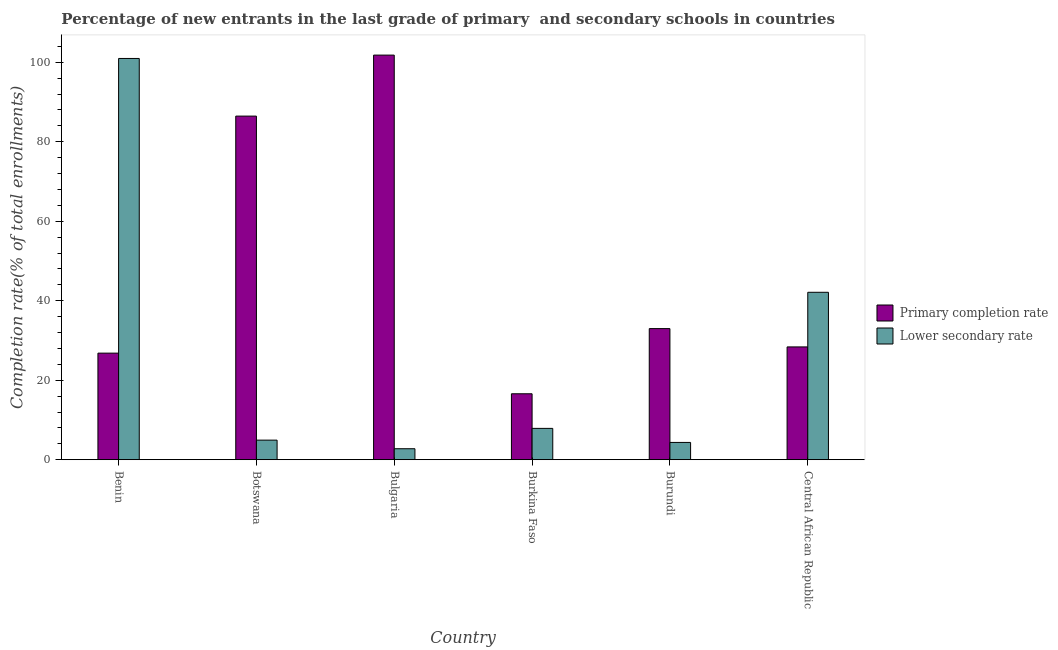How many different coloured bars are there?
Your answer should be compact. 2. How many groups of bars are there?
Ensure brevity in your answer.  6. Are the number of bars on each tick of the X-axis equal?
Offer a very short reply. Yes. How many bars are there on the 4th tick from the left?
Your response must be concise. 2. How many bars are there on the 4th tick from the right?
Provide a short and direct response. 2. What is the label of the 6th group of bars from the left?
Your response must be concise. Central African Republic. What is the completion rate in secondary schools in Burundi?
Make the answer very short. 4.35. Across all countries, what is the maximum completion rate in secondary schools?
Provide a succinct answer. 100.95. Across all countries, what is the minimum completion rate in secondary schools?
Ensure brevity in your answer.  2.76. In which country was the completion rate in primary schools maximum?
Give a very brief answer. Bulgaria. In which country was the completion rate in primary schools minimum?
Offer a terse response. Burkina Faso. What is the total completion rate in secondary schools in the graph?
Offer a terse response. 162.97. What is the difference between the completion rate in secondary schools in Botswana and that in Central African Republic?
Provide a succinct answer. -37.19. What is the difference between the completion rate in secondary schools in Burundi and the completion rate in primary schools in Botswana?
Keep it short and to the point. -82.1. What is the average completion rate in secondary schools per country?
Provide a short and direct response. 27.16. What is the difference between the completion rate in secondary schools and completion rate in primary schools in Bulgaria?
Keep it short and to the point. -99.03. In how many countries, is the completion rate in primary schools greater than 8 %?
Provide a succinct answer. 6. What is the ratio of the completion rate in secondary schools in Bulgaria to that in Burkina Faso?
Provide a succinct answer. 0.35. Is the completion rate in primary schools in Benin less than that in Burundi?
Make the answer very short. Yes. Is the difference between the completion rate in primary schools in Bulgaria and Burundi greater than the difference between the completion rate in secondary schools in Bulgaria and Burundi?
Give a very brief answer. Yes. What is the difference between the highest and the second highest completion rate in primary schools?
Provide a short and direct response. 15.35. What is the difference between the highest and the lowest completion rate in primary schools?
Your response must be concise. 85.2. What does the 1st bar from the left in Botswana represents?
Offer a very short reply. Primary completion rate. What does the 1st bar from the right in Central African Republic represents?
Offer a terse response. Lower secondary rate. What is the difference between two consecutive major ticks on the Y-axis?
Ensure brevity in your answer.  20. Does the graph contain any zero values?
Offer a very short reply. No. Where does the legend appear in the graph?
Your answer should be compact. Center right. How are the legend labels stacked?
Your response must be concise. Vertical. What is the title of the graph?
Make the answer very short. Percentage of new entrants in the last grade of primary  and secondary schools in countries. Does "Net savings(excluding particulate emission damage)" appear as one of the legend labels in the graph?
Offer a very short reply. No. What is the label or title of the Y-axis?
Your answer should be very brief. Completion rate(% of total enrollments). What is the Completion rate(% of total enrollments) in Primary completion rate in Benin?
Keep it short and to the point. 26.81. What is the Completion rate(% of total enrollments) in Lower secondary rate in Benin?
Provide a short and direct response. 100.95. What is the Completion rate(% of total enrollments) of Primary completion rate in Botswana?
Provide a short and direct response. 86.44. What is the Completion rate(% of total enrollments) in Lower secondary rate in Botswana?
Your answer should be compact. 4.92. What is the Completion rate(% of total enrollments) of Primary completion rate in Bulgaria?
Ensure brevity in your answer.  101.79. What is the Completion rate(% of total enrollments) of Lower secondary rate in Bulgaria?
Make the answer very short. 2.76. What is the Completion rate(% of total enrollments) of Primary completion rate in Burkina Faso?
Offer a terse response. 16.59. What is the Completion rate(% of total enrollments) of Lower secondary rate in Burkina Faso?
Your response must be concise. 7.88. What is the Completion rate(% of total enrollments) of Primary completion rate in Burundi?
Make the answer very short. 32.98. What is the Completion rate(% of total enrollments) of Lower secondary rate in Burundi?
Your answer should be very brief. 4.35. What is the Completion rate(% of total enrollments) in Primary completion rate in Central African Republic?
Offer a terse response. 28.38. What is the Completion rate(% of total enrollments) in Lower secondary rate in Central African Republic?
Your answer should be compact. 42.12. Across all countries, what is the maximum Completion rate(% of total enrollments) in Primary completion rate?
Your response must be concise. 101.79. Across all countries, what is the maximum Completion rate(% of total enrollments) of Lower secondary rate?
Your answer should be compact. 100.95. Across all countries, what is the minimum Completion rate(% of total enrollments) in Primary completion rate?
Ensure brevity in your answer.  16.59. Across all countries, what is the minimum Completion rate(% of total enrollments) in Lower secondary rate?
Keep it short and to the point. 2.76. What is the total Completion rate(% of total enrollments) in Primary completion rate in the graph?
Your answer should be compact. 292.99. What is the total Completion rate(% of total enrollments) of Lower secondary rate in the graph?
Your answer should be compact. 162.97. What is the difference between the Completion rate(% of total enrollments) in Primary completion rate in Benin and that in Botswana?
Offer a very short reply. -59.63. What is the difference between the Completion rate(% of total enrollments) in Lower secondary rate in Benin and that in Botswana?
Provide a succinct answer. 96.02. What is the difference between the Completion rate(% of total enrollments) in Primary completion rate in Benin and that in Bulgaria?
Your answer should be very brief. -74.98. What is the difference between the Completion rate(% of total enrollments) in Lower secondary rate in Benin and that in Bulgaria?
Offer a terse response. 98.19. What is the difference between the Completion rate(% of total enrollments) of Primary completion rate in Benin and that in Burkina Faso?
Offer a terse response. 10.22. What is the difference between the Completion rate(% of total enrollments) of Lower secondary rate in Benin and that in Burkina Faso?
Your answer should be very brief. 93.07. What is the difference between the Completion rate(% of total enrollments) of Primary completion rate in Benin and that in Burundi?
Offer a very short reply. -6.17. What is the difference between the Completion rate(% of total enrollments) of Lower secondary rate in Benin and that in Burundi?
Your answer should be compact. 96.6. What is the difference between the Completion rate(% of total enrollments) in Primary completion rate in Benin and that in Central African Republic?
Ensure brevity in your answer.  -1.56. What is the difference between the Completion rate(% of total enrollments) in Lower secondary rate in Benin and that in Central African Republic?
Offer a terse response. 58.83. What is the difference between the Completion rate(% of total enrollments) of Primary completion rate in Botswana and that in Bulgaria?
Your answer should be compact. -15.35. What is the difference between the Completion rate(% of total enrollments) of Lower secondary rate in Botswana and that in Bulgaria?
Your answer should be compact. 2.16. What is the difference between the Completion rate(% of total enrollments) of Primary completion rate in Botswana and that in Burkina Faso?
Make the answer very short. 69.86. What is the difference between the Completion rate(% of total enrollments) of Lower secondary rate in Botswana and that in Burkina Faso?
Your answer should be very brief. -2.95. What is the difference between the Completion rate(% of total enrollments) in Primary completion rate in Botswana and that in Burundi?
Offer a terse response. 53.46. What is the difference between the Completion rate(% of total enrollments) of Lower secondary rate in Botswana and that in Burundi?
Make the answer very short. 0.58. What is the difference between the Completion rate(% of total enrollments) of Primary completion rate in Botswana and that in Central African Republic?
Your answer should be very brief. 58.07. What is the difference between the Completion rate(% of total enrollments) in Lower secondary rate in Botswana and that in Central African Republic?
Give a very brief answer. -37.19. What is the difference between the Completion rate(% of total enrollments) in Primary completion rate in Bulgaria and that in Burkina Faso?
Offer a terse response. 85.2. What is the difference between the Completion rate(% of total enrollments) in Lower secondary rate in Bulgaria and that in Burkina Faso?
Your answer should be very brief. -5.12. What is the difference between the Completion rate(% of total enrollments) of Primary completion rate in Bulgaria and that in Burundi?
Your answer should be compact. 68.81. What is the difference between the Completion rate(% of total enrollments) of Lower secondary rate in Bulgaria and that in Burundi?
Your answer should be very brief. -1.59. What is the difference between the Completion rate(% of total enrollments) of Primary completion rate in Bulgaria and that in Central African Republic?
Keep it short and to the point. 73.41. What is the difference between the Completion rate(% of total enrollments) of Lower secondary rate in Bulgaria and that in Central African Republic?
Offer a terse response. -39.36. What is the difference between the Completion rate(% of total enrollments) in Primary completion rate in Burkina Faso and that in Burundi?
Your response must be concise. -16.4. What is the difference between the Completion rate(% of total enrollments) of Lower secondary rate in Burkina Faso and that in Burundi?
Offer a very short reply. 3.53. What is the difference between the Completion rate(% of total enrollments) in Primary completion rate in Burkina Faso and that in Central African Republic?
Make the answer very short. -11.79. What is the difference between the Completion rate(% of total enrollments) in Lower secondary rate in Burkina Faso and that in Central African Republic?
Keep it short and to the point. -34.24. What is the difference between the Completion rate(% of total enrollments) in Primary completion rate in Burundi and that in Central African Republic?
Ensure brevity in your answer.  4.61. What is the difference between the Completion rate(% of total enrollments) of Lower secondary rate in Burundi and that in Central African Republic?
Give a very brief answer. -37.77. What is the difference between the Completion rate(% of total enrollments) in Primary completion rate in Benin and the Completion rate(% of total enrollments) in Lower secondary rate in Botswana?
Make the answer very short. 21.89. What is the difference between the Completion rate(% of total enrollments) in Primary completion rate in Benin and the Completion rate(% of total enrollments) in Lower secondary rate in Bulgaria?
Provide a short and direct response. 24.05. What is the difference between the Completion rate(% of total enrollments) of Primary completion rate in Benin and the Completion rate(% of total enrollments) of Lower secondary rate in Burkina Faso?
Your answer should be very brief. 18.93. What is the difference between the Completion rate(% of total enrollments) in Primary completion rate in Benin and the Completion rate(% of total enrollments) in Lower secondary rate in Burundi?
Keep it short and to the point. 22.47. What is the difference between the Completion rate(% of total enrollments) of Primary completion rate in Benin and the Completion rate(% of total enrollments) of Lower secondary rate in Central African Republic?
Offer a terse response. -15.3. What is the difference between the Completion rate(% of total enrollments) of Primary completion rate in Botswana and the Completion rate(% of total enrollments) of Lower secondary rate in Bulgaria?
Keep it short and to the point. 83.68. What is the difference between the Completion rate(% of total enrollments) in Primary completion rate in Botswana and the Completion rate(% of total enrollments) in Lower secondary rate in Burkina Faso?
Provide a succinct answer. 78.57. What is the difference between the Completion rate(% of total enrollments) of Primary completion rate in Botswana and the Completion rate(% of total enrollments) of Lower secondary rate in Burundi?
Ensure brevity in your answer.  82.1. What is the difference between the Completion rate(% of total enrollments) of Primary completion rate in Botswana and the Completion rate(% of total enrollments) of Lower secondary rate in Central African Republic?
Give a very brief answer. 44.33. What is the difference between the Completion rate(% of total enrollments) in Primary completion rate in Bulgaria and the Completion rate(% of total enrollments) in Lower secondary rate in Burkina Faso?
Your answer should be very brief. 93.91. What is the difference between the Completion rate(% of total enrollments) in Primary completion rate in Bulgaria and the Completion rate(% of total enrollments) in Lower secondary rate in Burundi?
Make the answer very short. 97.44. What is the difference between the Completion rate(% of total enrollments) in Primary completion rate in Bulgaria and the Completion rate(% of total enrollments) in Lower secondary rate in Central African Republic?
Ensure brevity in your answer.  59.67. What is the difference between the Completion rate(% of total enrollments) in Primary completion rate in Burkina Faso and the Completion rate(% of total enrollments) in Lower secondary rate in Burundi?
Make the answer very short. 12.24. What is the difference between the Completion rate(% of total enrollments) of Primary completion rate in Burkina Faso and the Completion rate(% of total enrollments) of Lower secondary rate in Central African Republic?
Your answer should be compact. -25.53. What is the difference between the Completion rate(% of total enrollments) in Primary completion rate in Burundi and the Completion rate(% of total enrollments) in Lower secondary rate in Central African Republic?
Provide a short and direct response. -9.13. What is the average Completion rate(% of total enrollments) in Primary completion rate per country?
Your answer should be compact. 48.83. What is the average Completion rate(% of total enrollments) of Lower secondary rate per country?
Give a very brief answer. 27.16. What is the difference between the Completion rate(% of total enrollments) in Primary completion rate and Completion rate(% of total enrollments) in Lower secondary rate in Benin?
Keep it short and to the point. -74.14. What is the difference between the Completion rate(% of total enrollments) of Primary completion rate and Completion rate(% of total enrollments) of Lower secondary rate in Botswana?
Make the answer very short. 81.52. What is the difference between the Completion rate(% of total enrollments) of Primary completion rate and Completion rate(% of total enrollments) of Lower secondary rate in Bulgaria?
Provide a succinct answer. 99.03. What is the difference between the Completion rate(% of total enrollments) in Primary completion rate and Completion rate(% of total enrollments) in Lower secondary rate in Burkina Faso?
Provide a short and direct response. 8.71. What is the difference between the Completion rate(% of total enrollments) in Primary completion rate and Completion rate(% of total enrollments) in Lower secondary rate in Burundi?
Keep it short and to the point. 28.64. What is the difference between the Completion rate(% of total enrollments) of Primary completion rate and Completion rate(% of total enrollments) of Lower secondary rate in Central African Republic?
Make the answer very short. -13.74. What is the ratio of the Completion rate(% of total enrollments) in Primary completion rate in Benin to that in Botswana?
Your answer should be very brief. 0.31. What is the ratio of the Completion rate(% of total enrollments) of Lower secondary rate in Benin to that in Botswana?
Your response must be concise. 20.51. What is the ratio of the Completion rate(% of total enrollments) in Primary completion rate in Benin to that in Bulgaria?
Keep it short and to the point. 0.26. What is the ratio of the Completion rate(% of total enrollments) in Lower secondary rate in Benin to that in Bulgaria?
Ensure brevity in your answer.  36.6. What is the ratio of the Completion rate(% of total enrollments) in Primary completion rate in Benin to that in Burkina Faso?
Offer a terse response. 1.62. What is the ratio of the Completion rate(% of total enrollments) in Lower secondary rate in Benin to that in Burkina Faso?
Your answer should be compact. 12.82. What is the ratio of the Completion rate(% of total enrollments) of Primary completion rate in Benin to that in Burundi?
Keep it short and to the point. 0.81. What is the ratio of the Completion rate(% of total enrollments) in Lower secondary rate in Benin to that in Burundi?
Keep it short and to the point. 23.23. What is the ratio of the Completion rate(% of total enrollments) of Primary completion rate in Benin to that in Central African Republic?
Your answer should be compact. 0.94. What is the ratio of the Completion rate(% of total enrollments) in Lower secondary rate in Benin to that in Central African Republic?
Make the answer very short. 2.4. What is the ratio of the Completion rate(% of total enrollments) in Primary completion rate in Botswana to that in Bulgaria?
Your response must be concise. 0.85. What is the ratio of the Completion rate(% of total enrollments) of Lower secondary rate in Botswana to that in Bulgaria?
Offer a very short reply. 1.78. What is the ratio of the Completion rate(% of total enrollments) in Primary completion rate in Botswana to that in Burkina Faso?
Your response must be concise. 5.21. What is the ratio of the Completion rate(% of total enrollments) of Lower secondary rate in Botswana to that in Burkina Faso?
Keep it short and to the point. 0.62. What is the ratio of the Completion rate(% of total enrollments) in Primary completion rate in Botswana to that in Burundi?
Ensure brevity in your answer.  2.62. What is the ratio of the Completion rate(% of total enrollments) in Lower secondary rate in Botswana to that in Burundi?
Your answer should be compact. 1.13. What is the ratio of the Completion rate(% of total enrollments) in Primary completion rate in Botswana to that in Central African Republic?
Ensure brevity in your answer.  3.05. What is the ratio of the Completion rate(% of total enrollments) in Lower secondary rate in Botswana to that in Central African Republic?
Provide a succinct answer. 0.12. What is the ratio of the Completion rate(% of total enrollments) in Primary completion rate in Bulgaria to that in Burkina Faso?
Give a very brief answer. 6.14. What is the ratio of the Completion rate(% of total enrollments) in Lower secondary rate in Bulgaria to that in Burkina Faso?
Your answer should be compact. 0.35. What is the ratio of the Completion rate(% of total enrollments) in Primary completion rate in Bulgaria to that in Burundi?
Provide a succinct answer. 3.09. What is the ratio of the Completion rate(% of total enrollments) of Lower secondary rate in Bulgaria to that in Burundi?
Offer a terse response. 0.63. What is the ratio of the Completion rate(% of total enrollments) in Primary completion rate in Bulgaria to that in Central African Republic?
Make the answer very short. 3.59. What is the ratio of the Completion rate(% of total enrollments) in Lower secondary rate in Bulgaria to that in Central African Republic?
Provide a short and direct response. 0.07. What is the ratio of the Completion rate(% of total enrollments) of Primary completion rate in Burkina Faso to that in Burundi?
Your answer should be very brief. 0.5. What is the ratio of the Completion rate(% of total enrollments) in Lower secondary rate in Burkina Faso to that in Burundi?
Offer a very short reply. 1.81. What is the ratio of the Completion rate(% of total enrollments) of Primary completion rate in Burkina Faso to that in Central African Republic?
Your answer should be very brief. 0.58. What is the ratio of the Completion rate(% of total enrollments) in Lower secondary rate in Burkina Faso to that in Central African Republic?
Give a very brief answer. 0.19. What is the ratio of the Completion rate(% of total enrollments) of Primary completion rate in Burundi to that in Central African Republic?
Provide a short and direct response. 1.16. What is the ratio of the Completion rate(% of total enrollments) of Lower secondary rate in Burundi to that in Central African Republic?
Provide a short and direct response. 0.1. What is the difference between the highest and the second highest Completion rate(% of total enrollments) in Primary completion rate?
Offer a terse response. 15.35. What is the difference between the highest and the second highest Completion rate(% of total enrollments) in Lower secondary rate?
Your answer should be very brief. 58.83. What is the difference between the highest and the lowest Completion rate(% of total enrollments) of Primary completion rate?
Your answer should be compact. 85.2. What is the difference between the highest and the lowest Completion rate(% of total enrollments) in Lower secondary rate?
Ensure brevity in your answer.  98.19. 